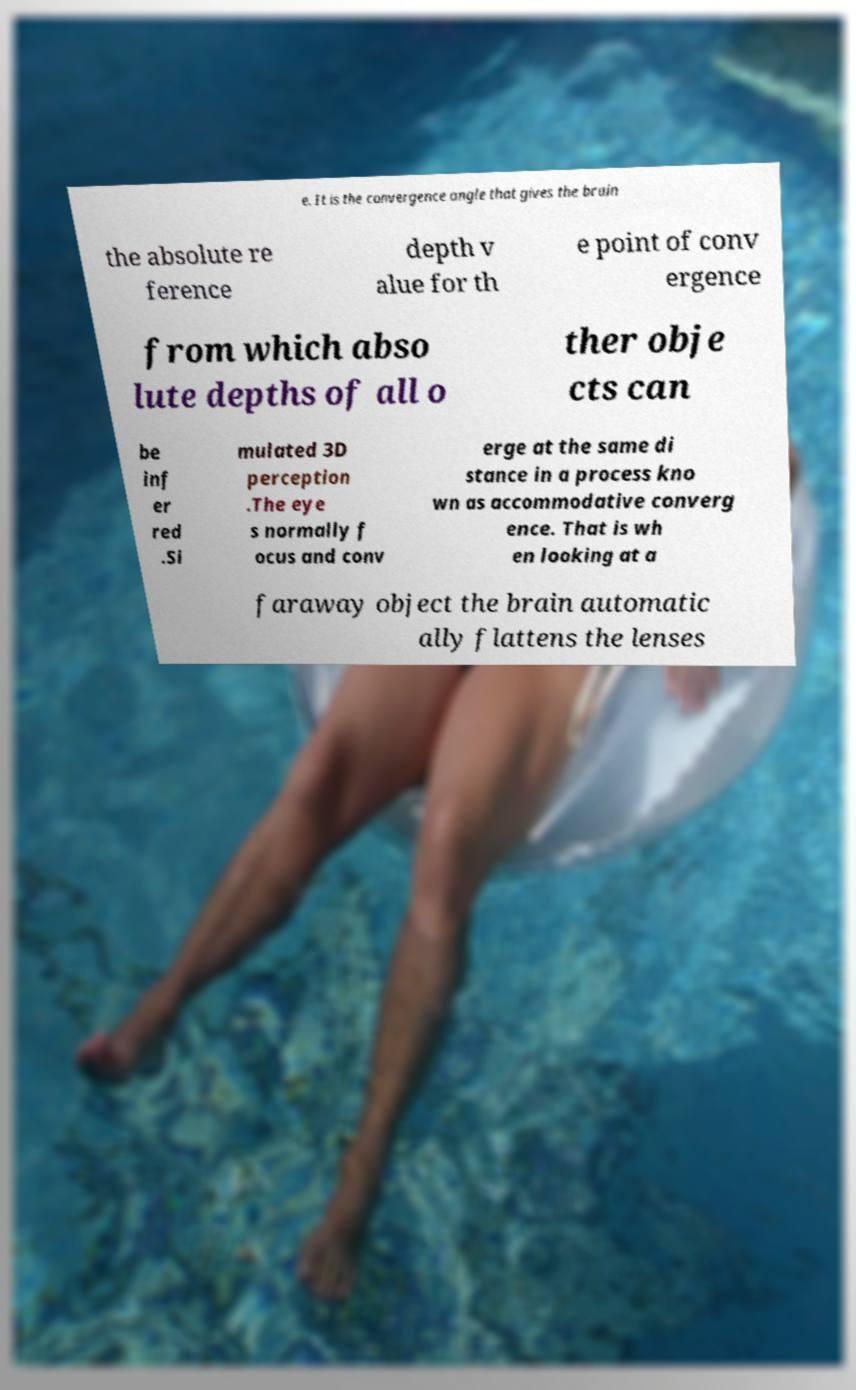What messages or text are displayed in this image? I need them in a readable, typed format. e. It is the convergence angle that gives the brain the absolute re ference depth v alue for th e point of conv ergence from which abso lute depths of all o ther obje cts can be inf er red .Si mulated 3D perception .The eye s normally f ocus and conv erge at the same di stance in a process kno wn as accommodative converg ence. That is wh en looking at a faraway object the brain automatic ally flattens the lenses 